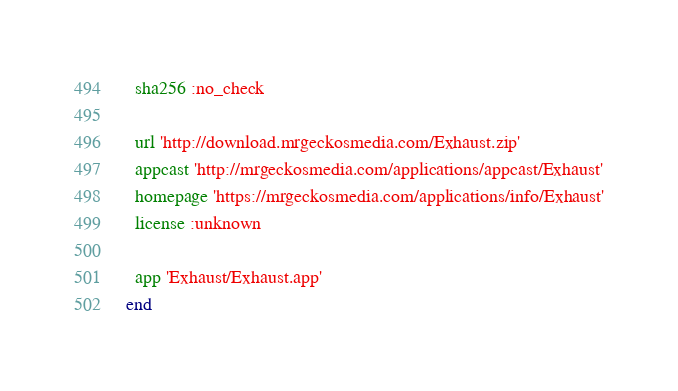<code> <loc_0><loc_0><loc_500><loc_500><_Ruby_>  sha256 :no_check

  url 'http://download.mrgeckosmedia.com/Exhaust.zip'
  appcast 'http://mrgeckosmedia.com/applications/appcast/Exhaust'
  homepage 'https://mrgeckosmedia.com/applications/info/Exhaust'
  license :unknown

  app 'Exhaust/Exhaust.app'
end
</code> 